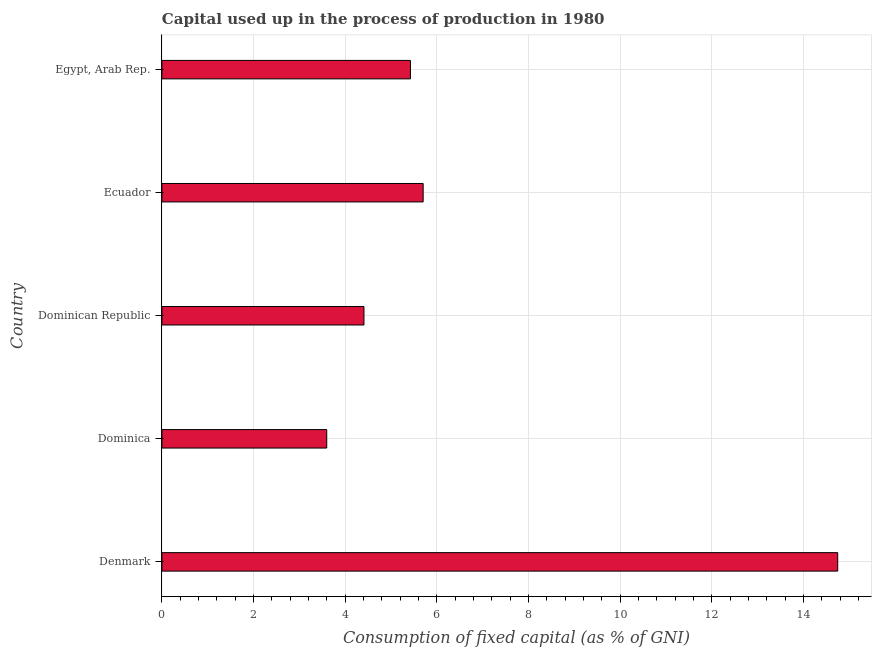Does the graph contain any zero values?
Provide a succinct answer. No. Does the graph contain grids?
Offer a very short reply. Yes. What is the title of the graph?
Your response must be concise. Capital used up in the process of production in 1980. What is the label or title of the X-axis?
Provide a short and direct response. Consumption of fixed capital (as % of GNI). What is the consumption of fixed capital in Dominica?
Your response must be concise. 3.6. Across all countries, what is the maximum consumption of fixed capital?
Make the answer very short. 14.75. Across all countries, what is the minimum consumption of fixed capital?
Offer a very short reply. 3.6. In which country was the consumption of fixed capital minimum?
Make the answer very short. Dominica. What is the sum of the consumption of fixed capital?
Your answer should be compact. 33.88. What is the difference between the consumption of fixed capital in Dominica and Egypt, Arab Rep.?
Your answer should be very brief. -1.83. What is the average consumption of fixed capital per country?
Give a very brief answer. 6.78. What is the median consumption of fixed capital?
Offer a very short reply. 5.42. What is the ratio of the consumption of fixed capital in Denmark to that in Egypt, Arab Rep.?
Provide a short and direct response. 2.72. Is the difference between the consumption of fixed capital in Dominican Republic and Egypt, Arab Rep. greater than the difference between any two countries?
Your answer should be very brief. No. What is the difference between the highest and the second highest consumption of fixed capital?
Your answer should be compact. 9.05. Is the sum of the consumption of fixed capital in Dominica and Egypt, Arab Rep. greater than the maximum consumption of fixed capital across all countries?
Make the answer very short. No. What is the difference between the highest and the lowest consumption of fixed capital?
Keep it short and to the point. 11.15. In how many countries, is the consumption of fixed capital greater than the average consumption of fixed capital taken over all countries?
Provide a succinct answer. 1. How many countries are there in the graph?
Provide a short and direct response. 5. What is the difference between two consecutive major ticks on the X-axis?
Provide a succinct answer. 2. Are the values on the major ticks of X-axis written in scientific E-notation?
Ensure brevity in your answer.  No. What is the Consumption of fixed capital (as % of GNI) of Denmark?
Provide a succinct answer. 14.75. What is the Consumption of fixed capital (as % of GNI) in Dominica?
Give a very brief answer. 3.6. What is the Consumption of fixed capital (as % of GNI) in Dominican Republic?
Provide a succinct answer. 4.41. What is the Consumption of fixed capital (as % of GNI) in Ecuador?
Your response must be concise. 5.7. What is the Consumption of fixed capital (as % of GNI) of Egypt, Arab Rep.?
Your response must be concise. 5.42. What is the difference between the Consumption of fixed capital (as % of GNI) in Denmark and Dominica?
Give a very brief answer. 11.15. What is the difference between the Consumption of fixed capital (as % of GNI) in Denmark and Dominican Republic?
Provide a succinct answer. 10.34. What is the difference between the Consumption of fixed capital (as % of GNI) in Denmark and Ecuador?
Your answer should be compact. 9.05. What is the difference between the Consumption of fixed capital (as % of GNI) in Denmark and Egypt, Arab Rep.?
Your answer should be compact. 9.32. What is the difference between the Consumption of fixed capital (as % of GNI) in Dominica and Dominican Republic?
Provide a succinct answer. -0.81. What is the difference between the Consumption of fixed capital (as % of GNI) in Dominica and Ecuador?
Give a very brief answer. -2.1. What is the difference between the Consumption of fixed capital (as % of GNI) in Dominica and Egypt, Arab Rep.?
Ensure brevity in your answer.  -1.83. What is the difference between the Consumption of fixed capital (as % of GNI) in Dominican Republic and Ecuador?
Your answer should be compact. -1.29. What is the difference between the Consumption of fixed capital (as % of GNI) in Dominican Republic and Egypt, Arab Rep.?
Make the answer very short. -1.01. What is the difference between the Consumption of fixed capital (as % of GNI) in Ecuador and Egypt, Arab Rep.?
Ensure brevity in your answer.  0.28. What is the ratio of the Consumption of fixed capital (as % of GNI) in Denmark to that in Dominica?
Your answer should be compact. 4.1. What is the ratio of the Consumption of fixed capital (as % of GNI) in Denmark to that in Dominican Republic?
Ensure brevity in your answer.  3.34. What is the ratio of the Consumption of fixed capital (as % of GNI) in Denmark to that in Ecuador?
Keep it short and to the point. 2.59. What is the ratio of the Consumption of fixed capital (as % of GNI) in Denmark to that in Egypt, Arab Rep.?
Your response must be concise. 2.72. What is the ratio of the Consumption of fixed capital (as % of GNI) in Dominica to that in Dominican Republic?
Provide a succinct answer. 0.82. What is the ratio of the Consumption of fixed capital (as % of GNI) in Dominica to that in Ecuador?
Make the answer very short. 0.63. What is the ratio of the Consumption of fixed capital (as % of GNI) in Dominica to that in Egypt, Arab Rep.?
Make the answer very short. 0.66. What is the ratio of the Consumption of fixed capital (as % of GNI) in Dominican Republic to that in Ecuador?
Your response must be concise. 0.77. What is the ratio of the Consumption of fixed capital (as % of GNI) in Dominican Republic to that in Egypt, Arab Rep.?
Provide a succinct answer. 0.81. What is the ratio of the Consumption of fixed capital (as % of GNI) in Ecuador to that in Egypt, Arab Rep.?
Ensure brevity in your answer.  1.05. 